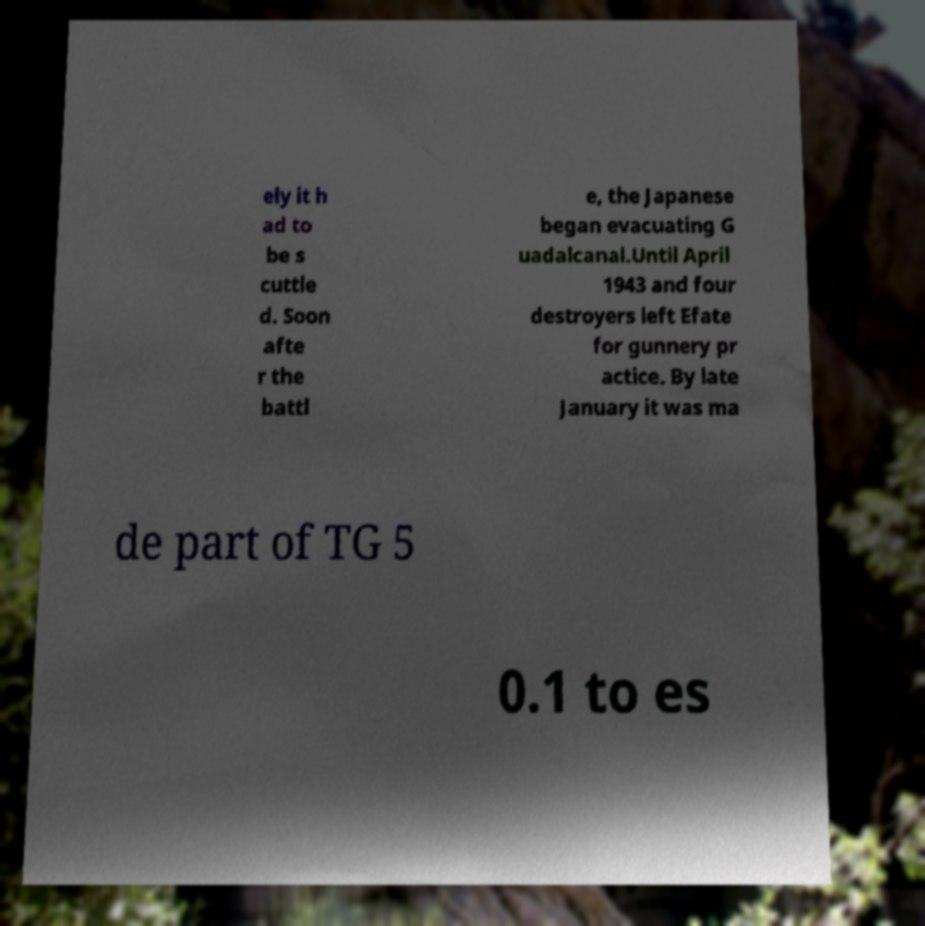I need the written content from this picture converted into text. Can you do that? ely it h ad to be s cuttle d. Soon afte r the battl e, the Japanese began evacuating G uadalcanal.Until April 1943 and four destroyers left Efate for gunnery pr actice. By late January it was ma de part of TG 5 0.1 to es 